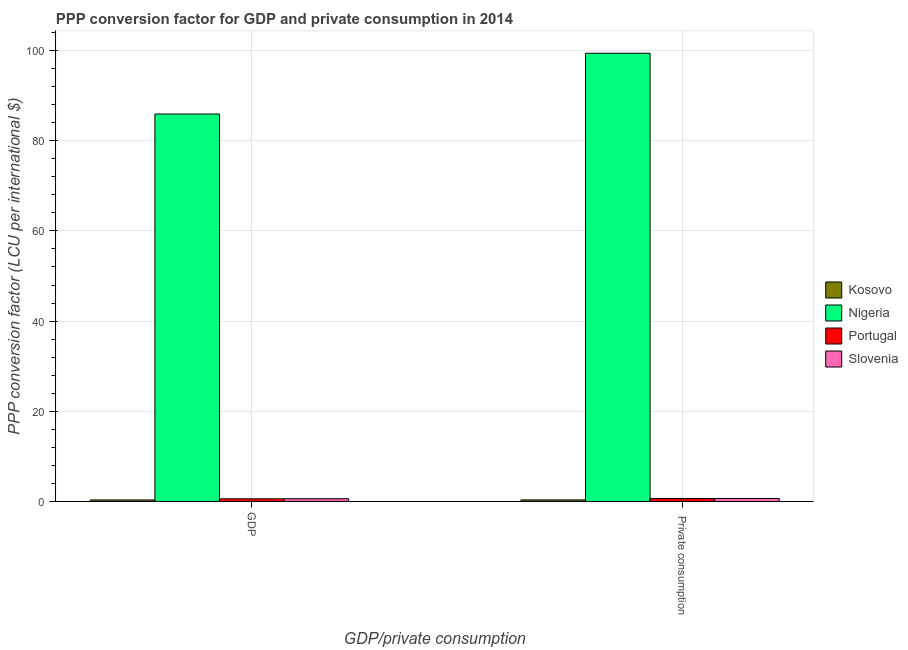How many different coloured bars are there?
Provide a short and direct response. 4. How many groups of bars are there?
Make the answer very short. 2. Are the number of bars per tick equal to the number of legend labels?
Your response must be concise. Yes. How many bars are there on the 2nd tick from the left?
Provide a succinct answer. 4. How many bars are there on the 2nd tick from the right?
Provide a succinct answer. 4. What is the label of the 2nd group of bars from the left?
Make the answer very short.  Private consumption. What is the ppp conversion factor for gdp in Slovenia?
Ensure brevity in your answer.  0.6. Across all countries, what is the maximum ppp conversion factor for gdp?
Ensure brevity in your answer.  85.92. Across all countries, what is the minimum ppp conversion factor for private consumption?
Give a very brief answer. 0.35. In which country was the ppp conversion factor for gdp maximum?
Provide a short and direct response. Nigeria. In which country was the ppp conversion factor for private consumption minimum?
Your answer should be compact. Kosovo. What is the total ppp conversion factor for gdp in the graph?
Give a very brief answer. 87.44. What is the difference between the ppp conversion factor for gdp in Portugal and that in Nigeria?
Offer a terse response. -85.33. What is the difference between the ppp conversion factor for private consumption in Slovenia and the ppp conversion factor for gdp in Nigeria?
Your answer should be compact. -85.25. What is the average ppp conversion factor for gdp per country?
Ensure brevity in your answer.  21.86. What is the difference between the ppp conversion factor for private consumption and ppp conversion factor for gdp in Kosovo?
Your answer should be compact. 0.01. In how many countries, is the ppp conversion factor for gdp greater than 40 LCU?
Your answer should be compact. 1. What is the ratio of the ppp conversion factor for gdp in Portugal to that in Slovenia?
Your answer should be very brief. 0.97. Is the ppp conversion factor for private consumption in Nigeria less than that in Slovenia?
Provide a short and direct response. No. In how many countries, is the ppp conversion factor for gdp greater than the average ppp conversion factor for gdp taken over all countries?
Keep it short and to the point. 1. What does the 1st bar from the left in GDP represents?
Give a very brief answer. Kosovo. What does the 2nd bar from the right in GDP represents?
Make the answer very short. Portugal. Are all the bars in the graph horizontal?
Provide a succinct answer. No. Are the values on the major ticks of Y-axis written in scientific E-notation?
Give a very brief answer. No. Does the graph contain grids?
Provide a succinct answer. Yes. Where does the legend appear in the graph?
Offer a very short reply. Center right. What is the title of the graph?
Offer a terse response. PPP conversion factor for GDP and private consumption in 2014. What is the label or title of the X-axis?
Make the answer very short. GDP/private consumption. What is the label or title of the Y-axis?
Your answer should be compact. PPP conversion factor (LCU per international $). What is the PPP conversion factor (LCU per international $) in Kosovo in GDP?
Ensure brevity in your answer.  0.34. What is the PPP conversion factor (LCU per international $) in Nigeria in GDP?
Provide a short and direct response. 85.92. What is the PPP conversion factor (LCU per international $) in Portugal in GDP?
Ensure brevity in your answer.  0.59. What is the PPP conversion factor (LCU per international $) in Slovenia in GDP?
Your answer should be compact. 0.6. What is the PPP conversion factor (LCU per international $) of Kosovo in  Private consumption?
Offer a terse response. 0.35. What is the PPP conversion factor (LCU per international $) of Nigeria in  Private consumption?
Your answer should be compact. 99.4. What is the PPP conversion factor (LCU per international $) in Portugal in  Private consumption?
Ensure brevity in your answer.  0.66. What is the PPP conversion factor (LCU per international $) in Slovenia in  Private consumption?
Provide a succinct answer. 0.67. Across all GDP/private consumption, what is the maximum PPP conversion factor (LCU per international $) in Kosovo?
Provide a succinct answer. 0.35. Across all GDP/private consumption, what is the maximum PPP conversion factor (LCU per international $) of Nigeria?
Offer a terse response. 99.4. Across all GDP/private consumption, what is the maximum PPP conversion factor (LCU per international $) of Portugal?
Offer a terse response. 0.66. Across all GDP/private consumption, what is the maximum PPP conversion factor (LCU per international $) in Slovenia?
Offer a very short reply. 0.67. Across all GDP/private consumption, what is the minimum PPP conversion factor (LCU per international $) in Kosovo?
Your answer should be compact. 0.34. Across all GDP/private consumption, what is the minimum PPP conversion factor (LCU per international $) in Nigeria?
Your response must be concise. 85.92. Across all GDP/private consumption, what is the minimum PPP conversion factor (LCU per international $) of Portugal?
Ensure brevity in your answer.  0.59. Across all GDP/private consumption, what is the minimum PPP conversion factor (LCU per international $) of Slovenia?
Make the answer very short. 0.6. What is the total PPP conversion factor (LCU per international $) in Kosovo in the graph?
Give a very brief answer. 0.68. What is the total PPP conversion factor (LCU per international $) of Nigeria in the graph?
Make the answer very short. 185.32. What is the total PPP conversion factor (LCU per international $) in Portugal in the graph?
Offer a terse response. 1.24. What is the total PPP conversion factor (LCU per international $) in Slovenia in the graph?
Make the answer very short. 1.27. What is the difference between the PPP conversion factor (LCU per international $) of Kosovo in GDP and that in  Private consumption?
Give a very brief answer. -0.01. What is the difference between the PPP conversion factor (LCU per international $) in Nigeria in GDP and that in  Private consumption?
Your answer should be very brief. -13.48. What is the difference between the PPP conversion factor (LCU per international $) in Portugal in GDP and that in  Private consumption?
Give a very brief answer. -0.07. What is the difference between the PPP conversion factor (LCU per international $) in Slovenia in GDP and that in  Private consumption?
Your response must be concise. -0.06. What is the difference between the PPP conversion factor (LCU per international $) in Kosovo in GDP and the PPP conversion factor (LCU per international $) in Nigeria in  Private consumption?
Provide a short and direct response. -99.06. What is the difference between the PPP conversion factor (LCU per international $) in Kosovo in GDP and the PPP conversion factor (LCU per international $) in Portugal in  Private consumption?
Give a very brief answer. -0.32. What is the difference between the PPP conversion factor (LCU per international $) of Kosovo in GDP and the PPP conversion factor (LCU per international $) of Slovenia in  Private consumption?
Keep it short and to the point. -0.33. What is the difference between the PPP conversion factor (LCU per international $) in Nigeria in GDP and the PPP conversion factor (LCU per international $) in Portugal in  Private consumption?
Your response must be concise. 85.26. What is the difference between the PPP conversion factor (LCU per international $) in Nigeria in GDP and the PPP conversion factor (LCU per international $) in Slovenia in  Private consumption?
Ensure brevity in your answer.  85.25. What is the difference between the PPP conversion factor (LCU per international $) in Portugal in GDP and the PPP conversion factor (LCU per international $) in Slovenia in  Private consumption?
Offer a terse response. -0.08. What is the average PPP conversion factor (LCU per international $) in Kosovo per GDP/private consumption?
Offer a terse response. 0.34. What is the average PPP conversion factor (LCU per international $) in Nigeria per GDP/private consumption?
Make the answer very short. 92.66. What is the average PPP conversion factor (LCU per international $) of Portugal per GDP/private consumption?
Your answer should be very brief. 0.62. What is the average PPP conversion factor (LCU per international $) in Slovenia per GDP/private consumption?
Make the answer very short. 0.64. What is the difference between the PPP conversion factor (LCU per international $) in Kosovo and PPP conversion factor (LCU per international $) in Nigeria in GDP?
Give a very brief answer. -85.58. What is the difference between the PPP conversion factor (LCU per international $) of Kosovo and PPP conversion factor (LCU per international $) of Portugal in GDP?
Give a very brief answer. -0.25. What is the difference between the PPP conversion factor (LCU per international $) of Kosovo and PPP conversion factor (LCU per international $) of Slovenia in GDP?
Ensure brevity in your answer.  -0.27. What is the difference between the PPP conversion factor (LCU per international $) of Nigeria and PPP conversion factor (LCU per international $) of Portugal in GDP?
Offer a terse response. 85.33. What is the difference between the PPP conversion factor (LCU per international $) of Nigeria and PPP conversion factor (LCU per international $) of Slovenia in GDP?
Keep it short and to the point. 85.31. What is the difference between the PPP conversion factor (LCU per international $) of Portugal and PPP conversion factor (LCU per international $) of Slovenia in GDP?
Ensure brevity in your answer.  -0.02. What is the difference between the PPP conversion factor (LCU per international $) in Kosovo and PPP conversion factor (LCU per international $) in Nigeria in  Private consumption?
Provide a short and direct response. -99.05. What is the difference between the PPP conversion factor (LCU per international $) in Kosovo and PPP conversion factor (LCU per international $) in Portugal in  Private consumption?
Your answer should be very brief. -0.31. What is the difference between the PPP conversion factor (LCU per international $) in Kosovo and PPP conversion factor (LCU per international $) in Slovenia in  Private consumption?
Your response must be concise. -0.32. What is the difference between the PPP conversion factor (LCU per international $) in Nigeria and PPP conversion factor (LCU per international $) in Portugal in  Private consumption?
Provide a short and direct response. 98.74. What is the difference between the PPP conversion factor (LCU per international $) of Nigeria and PPP conversion factor (LCU per international $) of Slovenia in  Private consumption?
Give a very brief answer. 98.73. What is the difference between the PPP conversion factor (LCU per international $) of Portugal and PPP conversion factor (LCU per international $) of Slovenia in  Private consumption?
Give a very brief answer. -0.01. What is the ratio of the PPP conversion factor (LCU per international $) of Kosovo in GDP to that in  Private consumption?
Offer a terse response. 0.97. What is the ratio of the PPP conversion factor (LCU per international $) in Nigeria in GDP to that in  Private consumption?
Provide a short and direct response. 0.86. What is the ratio of the PPP conversion factor (LCU per international $) of Portugal in GDP to that in  Private consumption?
Offer a terse response. 0.89. What is the ratio of the PPP conversion factor (LCU per international $) in Slovenia in GDP to that in  Private consumption?
Make the answer very short. 0.9. What is the difference between the highest and the second highest PPP conversion factor (LCU per international $) in Kosovo?
Provide a short and direct response. 0.01. What is the difference between the highest and the second highest PPP conversion factor (LCU per international $) in Nigeria?
Your answer should be compact. 13.48. What is the difference between the highest and the second highest PPP conversion factor (LCU per international $) of Portugal?
Your answer should be compact. 0.07. What is the difference between the highest and the second highest PPP conversion factor (LCU per international $) in Slovenia?
Make the answer very short. 0.06. What is the difference between the highest and the lowest PPP conversion factor (LCU per international $) in Kosovo?
Your answer should be compact. 0.01. What is the difference between the highest and the lowest PPP conversion factor (LCU per international $) in Nigeria?
Your answer should be very brief. 13.48. What is the difference between the highest and the lowest PPP conversion factor (LCU per international $) in Portugal?
Offer a terse response. 0.07. What is the difference between the highest and the lowest PPP conversion factor (LCU per international $) in Slovenia?
Offer a terse response. 0.06. 